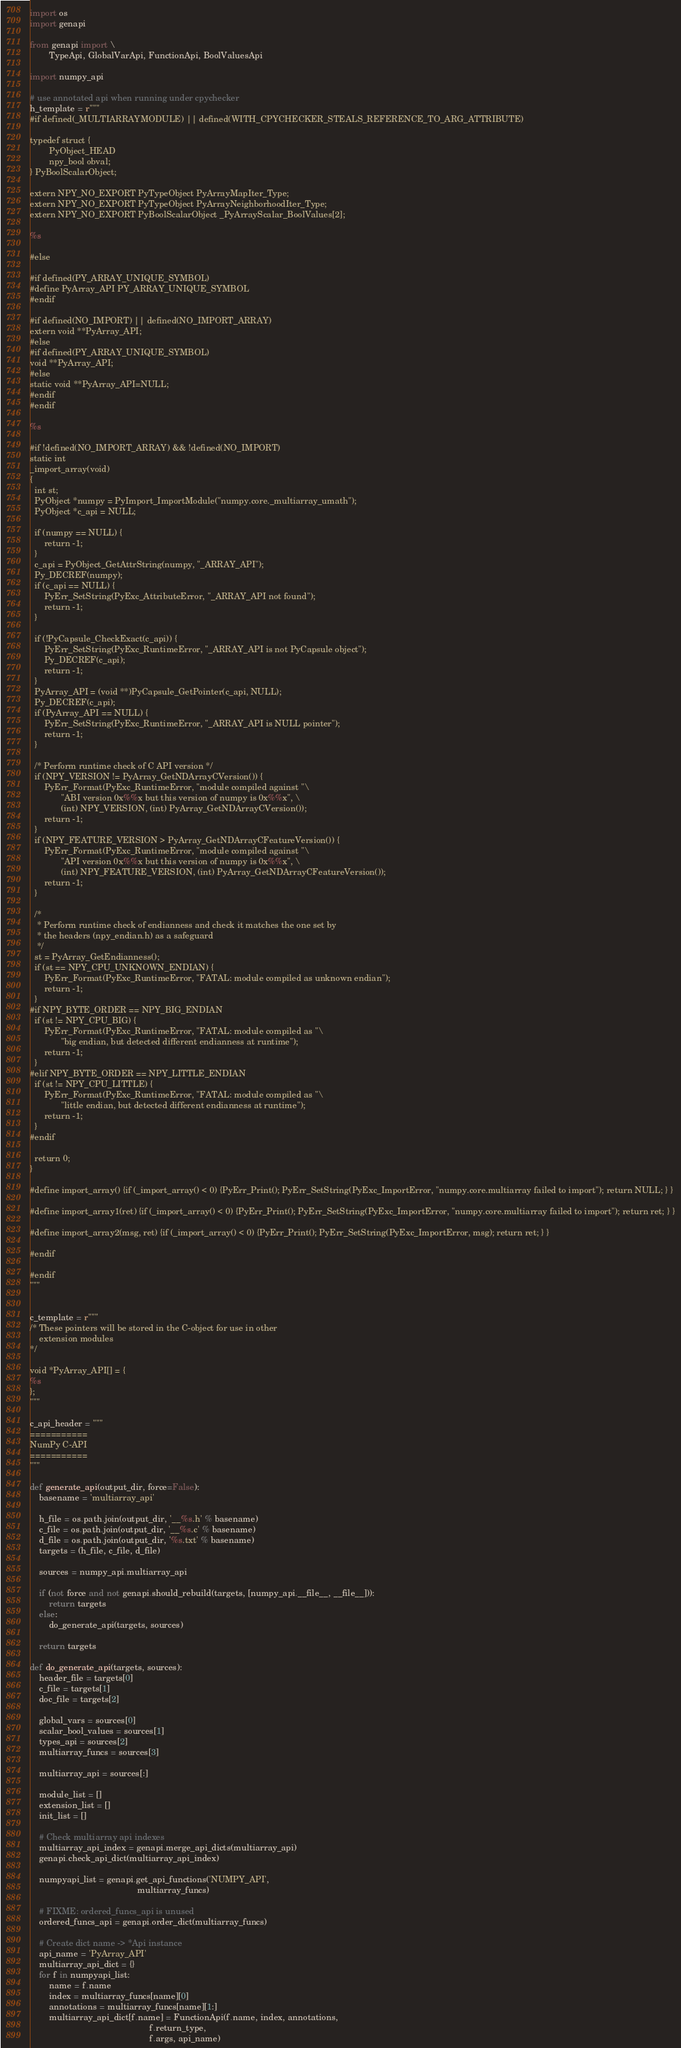<code> <loc_0><loc_0><loc_500><loc_500><_Python_>import os
import genapi

from genapi import \
        TypeApi, GlobalVarApi, FunctionApi, BoolValuesApi

import numpy_api

# use annotated api when running under cpychecker
h_template = r"""
#if defined(_MULTIARRAYMODULE) || defined(WITH_CPYCHECKER_STEALS_REFERENCE_TO_ARG_ATTRIBUTE)

typedef struct {
        PyObject_HEAD
        npy_bool obval;
} PyBoolScalarObject;

extern NPY_NO_EXPORT PyTypeObject PyArrayMapIter_Type;
extern NPY_NO_EXPORT PyTypeObject PyArrayNeighborhoodIter_Type;
extern NPY_NO_EXPORT PyBoolScalarObject _PyArrayScalar_BoolValues[2];

%s

#else

#if defined(PY_ARRAY_UNIQUE_SYMBOL)
#define PyArray_API PY_ARRAY_UNIQUE_SYMBOL
#endif

#if defined(NO_IMPORT) || defined(NO_IMPORT_ARRAY)
extern void **PyArray_API;
#else
#if defined(PY_ARRAY_UNIQUE_SYMBOL)
void **PyArray_API;
#else
static void **PyArray_API=NULL;
#endif
#endif

%s

#if !defined(NO_IMPORT_ARRAY) && !defined(NO_IMPORT)
static int
_import_array(void)
{
  int st;
  PyObject *numpy = PyImport_ImportModule("numpy.core._multiarray_umath");
  PyObject *c_api = NULL;

  if (numpy == NULL) {
      return -1;
  }
  c_api = PyObject_GetAttrString(numpy, "_ARRAY_API");
  Py_DECREF(numpy);
  if (c_api == NULL) {
      PyErr_SetString(PyExc_AttributeError, "_ARRAY_API not found");
      return -1;
  }

  if (!PyCapsule_CheckExact(c_api)) {
      PyErr_SetString(PyExc_RuntimeError, "_ARRAY_API is not PyCapsule object");
      Py_DECREF(c_api);
      return -1;
  }
  PyArray_API = (void **)PyCapsule_GetPointer(c_api, NULL);
  Py_DECREF(c_api);
  if (PyArray_API == NULL) {
      PyErr_SetString(PyExc_RuntimeError, "_ARRAY_API is NULL pointer");
      return -1;
  }

  /* Perform runtime check of C API version */
  if (NPY_VERSION != PyArray_GetNDArrayCVersion()) {
      PyErr_Format(PyExc_RuntimeError, "module compiled against "\
             "ABI version 0x%%x but this version of numpy is 0x%%x", \
             (int) NPY_VERSION, (int) PyArray_GetNDArrayCVersion());
      return -1;
  }
  if (NPY_FEATURE_VERSION > PyArray_GetNDArrayCFeatureVersion()) {
      PyErr_Format(PyExc_RuntimeError, "module compiled against "\
             "API version 0x%%x but this version of numpy is 0x%%x", \
             (int) NPY_FEATURE_VERSION, (int) PyArray_GetNDArrayCFeatureVersion());
      return -1;
  }

  /*
   * Perform runtime check of endianness and check it matches the one set by
   * the headers (npy_endian.h) as a safeguard
   */
  st = PyArray_GetEndianness();
  if (st == NPY_CPU_UNKNOWN_ENDIAN) {
      PyErr_Format(PyExc_RuntimeError, "FATAL: module compiled as unknown endian");
      return -1;
  }
#if NPY_BYTE_ORDER == NPY_BIG_ENDIAN
  if (st != NPY_CPU_BIG) {
      PyErr_Format(PyExc_RuntimeError, "FATAL: module compiled as "\
             "big endian, but detected different endianness at runtime");
      return -1;
  }
#elif NPY_BYTE_ORDER == NPY_LITTLE_ENDIAN
  if (st != NPY_CPU_LITTLE) {
      PyErr_Format(PyExc_RuntimeError, "FATAL: module compiled as "\
             "little endian, but detected different endianness at runtime");
      return -1;
  }
#endif

  return 0;
}

#define import_array() {if (_import_array() < 0) {PyErr_Print(); PyErr_SetString(PyExc_ImportError, "numpy.core.multiarray failed to import"); return NULL; } }

#define import_array1(ret) {if (_import_array() < 0) {PyErr_Print(); PyErr_SetString(PyExc_ImportError, "numpy.core.multiarray failed to import"); return ret; } }

#define import_array2(msg, ret) {if (_import_array() < 0) {PyErr_Print(); PyErr_SetString(PyExc_ImportError, msg); return ret; } }

#endif

#endif
"""


c_template = r"""
/* These pointers will be stored in the C-object for use in other
    extension modules
*/

void *PyArray_API[] = {
%s
};
"""

c_api_header = """
===========
NumPy C-API
===========
"""

def generate_api(output_dir, force=False):
    basename = 'multiarray_api'

    h_file = os.path.join(output_dir, '__%s.h' % basename)
    c_file = os.path.join(output_dir, '__%s.c' % basename)
    d_file = os.path.join(output_dir, '%s.txt' % basename)
    targets = (h_file, c_file, d_file)

    sources = numpy_api.multiarray_api

    if (not force and not genapi.should_rebuild(targets, [numpy_api.__file__, __file__])):
        return targets
    else:
        do_generate_api(targets, sources)

    return targets

def do_generate_api(targets, sources):
    header_file = targets[0]
    c_file = targets[1]
    doc_file = targets[2]

    global_vars = sources[0]
    scalar_bool_values = sources[1]
    types_api = sources[2]
    multiarray_funcs = sources[3]

    multiarray_api = sources[:]

    module_list = []
    extension_list = []
    init_list = []

    # Check multiarray api indexes
    multiarray_api_index = genapi.merge_api_dicts(multiarray_api)
    genapi.check_api_dict(multiarray_api_index)

    numpyapi_list = genapi.get_api_functions('NUMPY_API',
                                             multiarray_funcs)

    # FIXME: ordered_funcs_api is unused
    ordered_funcs_api = genapi.order_dict(multiarray_funcs)

    # Create dict name -> *Api instance
    api_name = 'PyArray_API'
    multiarray_api_dict = {}
    for f in numpyapi_list:
        name = f.name
        index = multiarray_funcs[name][0]
        annotations = multiarray_funcs[name][1:]
        multiarray_api_dict[f.name] = FunctionApi(f.name, index, annotations,
                                                  f.return_type,
                                                  f.args, api_name)
</code> 